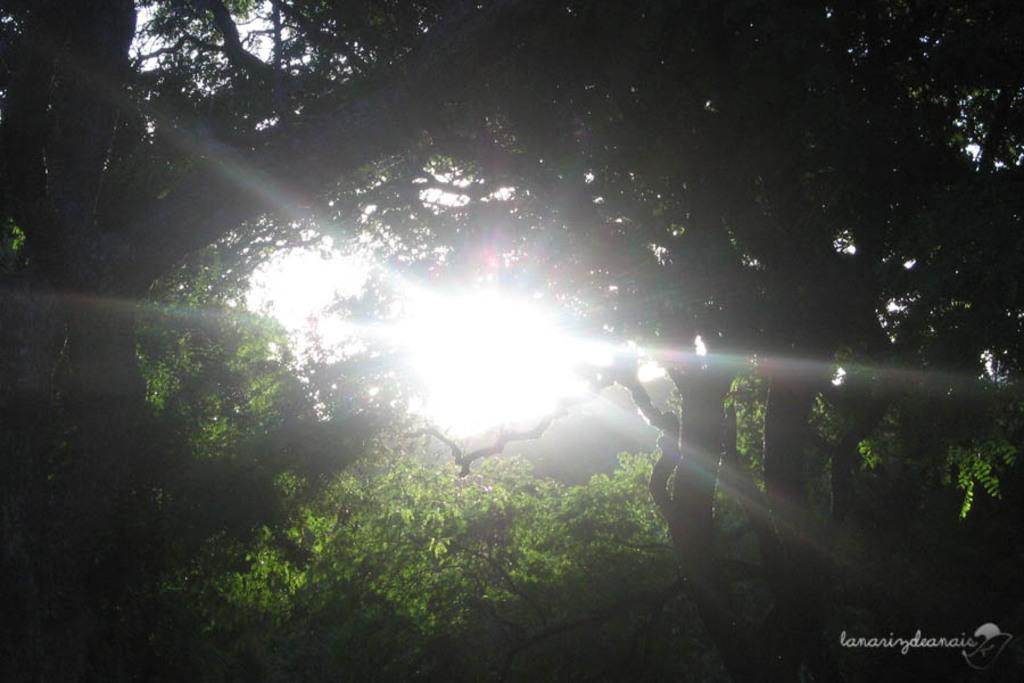What type of vegetation can be seen in the image? There are trees in the image. What celestial body is visible in the image? The sun is visible in the image. Is there any text or marking at the bottom of the image? Yes, there is a watermark at the bottom of the image. What type of orange is hanging from the trees in the image? There are no oranges present in the image; only trees can be seen. Is there any indication of death or a funeral in the image? No, there is no indication of death or a funeral in the image. Can you see a dock or any water-related structures in the image? No, there is no dock or any water-related structures visible in the image. 